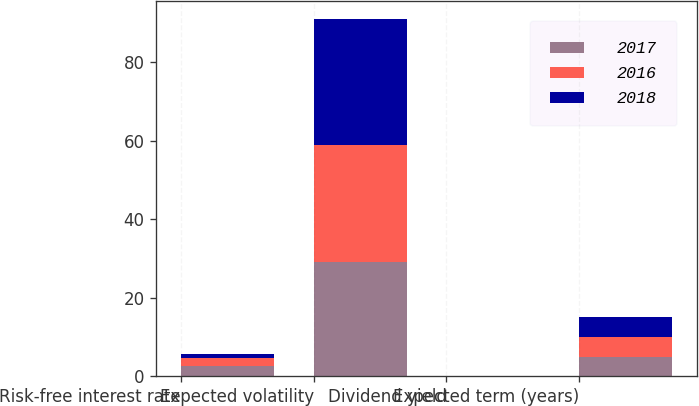<chart> <loc_0><loc_0><loc_500><loc_500><stacked_bar_chart><ecel><fcel>Risk-free interest rate<fcel>Expected volatility<fcel>Dividend yield<fcel>Expected term (years)<nl><fcel>2017<fcel>2.6<fcel>29<fcel>0.04<fcel>5<nl><fcel>2016<fcel>1.99<fcel>30<fcel>0.06<fcel>5<nl><fcel>2018<fcel>1.05<fcel>32<fcel>0.06<fcel>5<nl></chart> 